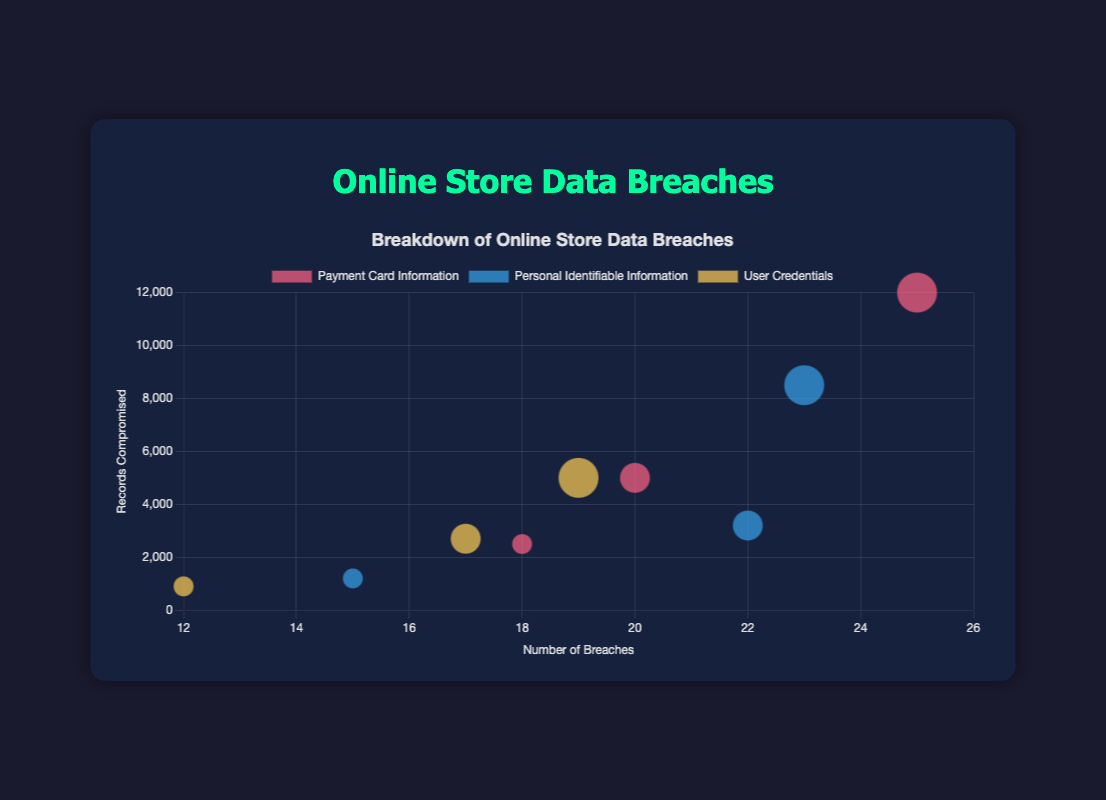What is the title of the bubble chart? The title of the chart is usually displayed at the top of the figure where it's clearly visible. In this case, the title is a clear descriptor of the chart's content.
Answer: Online Store Data Breaches Which type of data breach has the highest number of breaches among large businesses? To find the answer, look for the dataset related to large businesses and compare the number of breaches of each type of compromised data. The largest value indicates the highest number of breaches.
Answer: Payment Card Information How many records were compromised in medium-sized businesses for Personal Identifiable Information breaches? Locate the bubble representing medium-sized businesses with this type of data breach. The 'y' value of this bubble indicates the number of compromised records.
Answer: 3200 What is the difference in the number of breaches between small and large businesses for User Credentials breaches? Identify the number of breaches for User Credentials for small and large businesses. Subtract the smaller number (small businesses) from the larger one (large businesses).
Answer: 7 Which business size has the highest number of records compromised for Payment Card Information breaches? Compare the bubbles for Payment Card Information across small, medium, and large businesses. The bubble with the highest 'y' value indicates the highest number of compromised records.
Answer: Large What is the average number of breaches for medium-sized businesses across all data types? Calculate the average by adding the number of breaches for Payment Card Information, Personal Identifiable Information, and User Credentials in medium-sized businesses, then divide by 3.
Answer: 19.67 Which type of compromised data has the smallest bubble size for small businesses? Bubble size indicates the number of records compromised. Compare the sizes of bubbles for different types of data for small businesses. The data type with the smallest bubble corresponds to the smallest number of compromised records.
Answer: User Credentials How does the number of compromised records compare between small and large businesses for Personal Identifiable Information breaches? Look at the 'y' values for bubbles representing this type of breach in both small and large businesses and compare them directly.
Answer: Large businesses have significantly more compromised records Which data breach type and business size combination has the largest bubble on the chart? The largest bubble size indicates the highest number of compromised records. Scan the chart for the largest bubble and note its data type and business size.
Answer: Payment Card Information, Large 